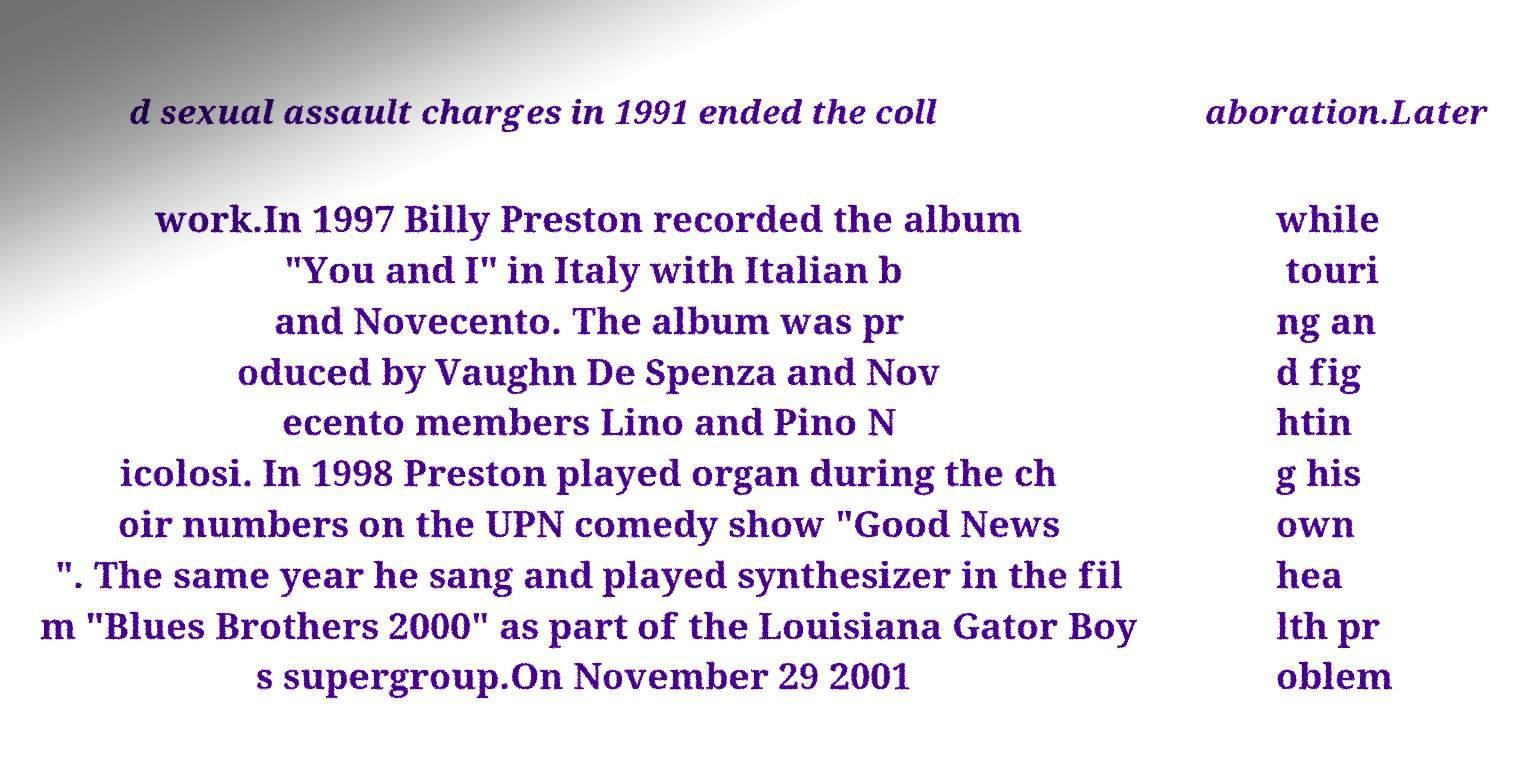I need the written content from this picture converted into text. Can you do that? d sexual assault charges in 1991 ended the coll aboration.Later work.In 1997 Billy Preston recorded the album "You and I" in Italy with Italian b and Novecento. The album was pr oduced by Vaughn De Spenza and Nov ecento members Lino and Pino N icolosi. In 1998 Preston played organ during the ch oir numbers on the UPN comedy show "Good News ". The same year he sang and played synthesizer in the fil m "Blues Brothers 2000" as part of the Louisiana Gator Boy s supergroup.On November 29 2001 while touri ng an d fig htin g his own hea lth pr oblem 